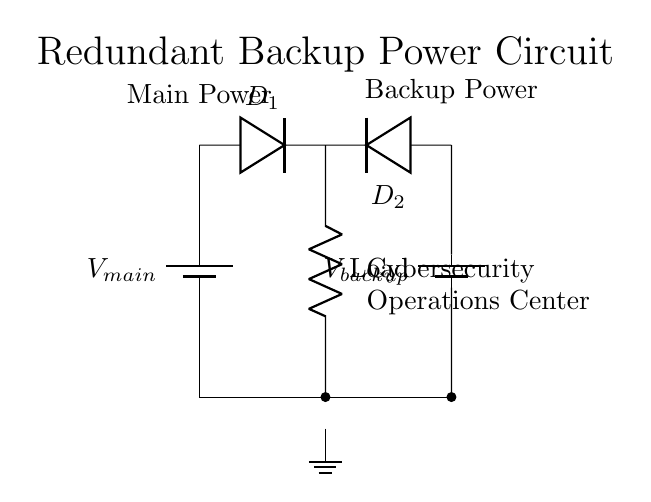What is the total number of batteries in this circuit? There are two batteries in the circuit, one labeled as the main power supply and the other as the backup power supply.
Answer: 2 What is the purpose of the diodes in this circuit? The diodes serve as isolation devices to prevent backflow of current, ensuring that only one battery supplies power to the load at a time based on availability.
Answer: Isolation What is the role of the resistor labeled as "Load"? The resistor named "Load" represents the component that consumes power in the circuit, simulating the demand typically found in a cybersecurity operations center.
Answer: Load What are the input voltages for this power supply circuit? The input voltages are from the two batteries, which are referred to as V_main for the main power supply and V_backup for the backup power supply.
Answer: V_main and V_backup What happens if the main power supply fails? If the main power supply fails, the backup power supply will take over and supply power to the load, maintaining operations without interruption.
Answer: Backup supply takes over What circuit configuration is used in this power supply design? The circuit configuration used is parallel, allowing multiple power sources to independently supply power to the load.
Answer: Parallel Which component connects the batteries to the load? The component that connects the batteries to the load is the resistive element labeled "Load," along with the diodes providing redundancy.
Answer: Load 